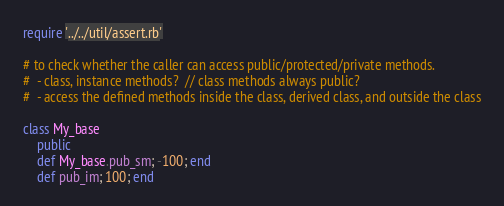Convert code to text. <code><loc_0><loc_0><loc_500><loc_500><_Ruby_>require '../../util/assert.rb'

# to check whether the caller can access public/protected/private methods.
#  - class, instance methods?  // class methods always public?
#  - access the defined methods inside the class, derived class, and outside the class

class My_base
    public 
    def My_base.pub_sm; -100; end
    def pub_im; 100; end </code> 